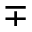Convert formula to latex. <formula><loc_0><loc_0><loc_500><loc_500>\mp</formula> 